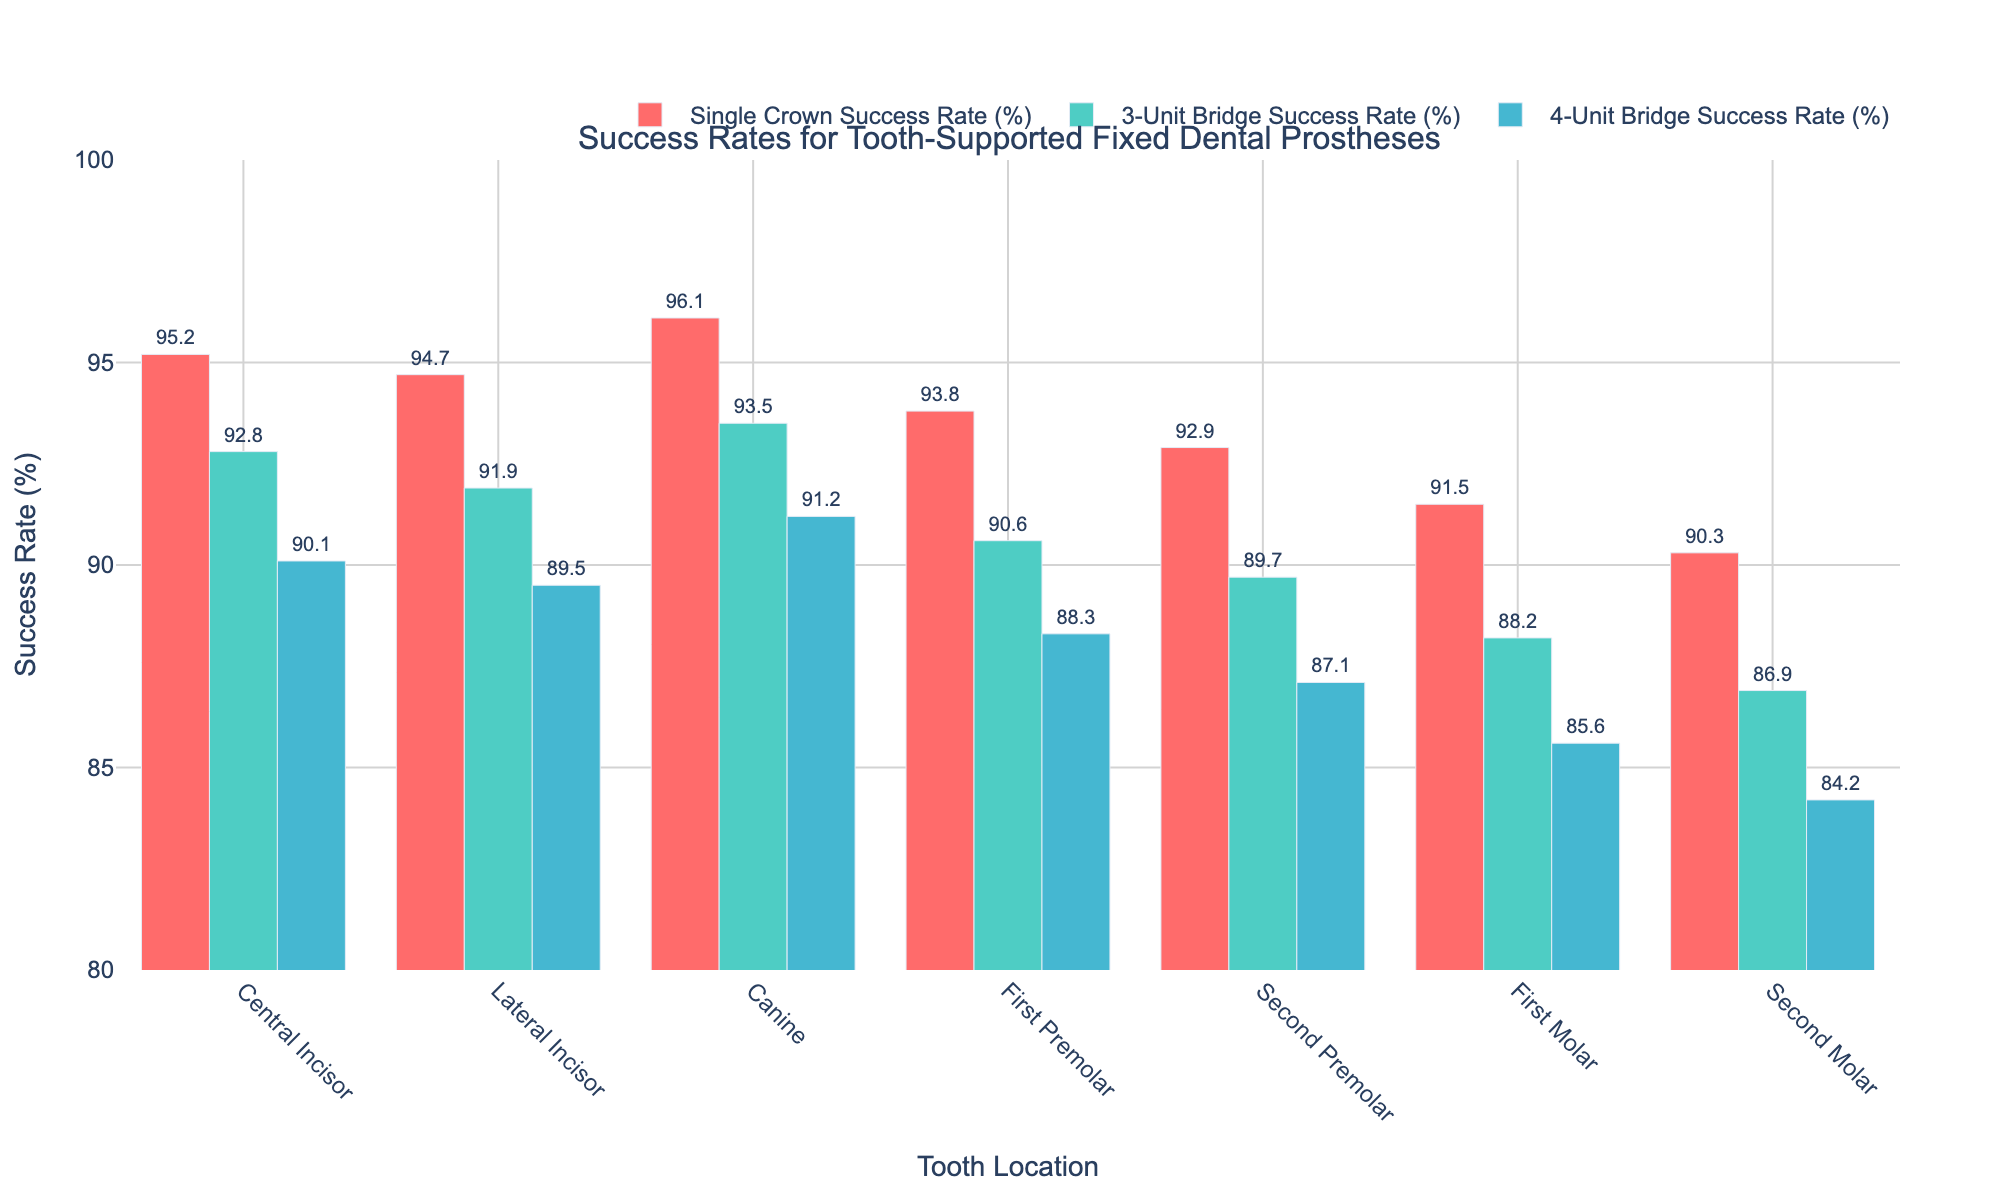What's the success rate of a 3-Unit Bridge for Canines? The figure shows a bar chart with success rates for various tooth-supported prostheses. Locate the bar for a 3-Unit Bridge under the "Canine" tooth location. The value is annotated directly on the bar.
Answer: 93.5% Which tooth location has the highest success rate for Single Crowns? Look at all the bars for Single Crown success rates across different tooth locations. The tallest bar corresponds to the highest success rate. Identify the tooth location.
Answer: Canine Comparing the success rates for Single Crowns and 4-Unit Bridges for the Central Incisor, which is higher? Locate the bars for Single Crowns and 4-Unit Bridges under the "Central Incisor" category. Compare their heights and the annotated values.
Answer: Single Crowns What is the difference in success rates between a 4-Unit Bridge for the First Molar and the Second Molar? Find the bars representing 4-Unit Bridge success rates for both the First and Second Molars. Subtract the success rate of the Second Molar from that of the First Molar.
Answer: 1.4% Which prosthesis type has the least variation in success rates across all tooth locations? Look at the range of heights (success rates) for each prosthesis type (Single Crown, 3-Unit Bridge, 4-Unit Bridge) across all tooth locations. The type with bars that have the smallest range of variation in height has the least variation.
Answer: 3-Unit Bridge What are the average success rates for 3-Unit Bridges and 4-Unit Bridges across all tooth locations? For 3-Unit Bridge: Sum the success rates for all tooth locations and divide by the number of locations. Similarly, do the same for 4-Unit Bridges. [3-Unit Bridge: (92.8 + 91.9 + 93.5 + 90.6 + 89.7 + 88.2 + 86.9) / 7 = 90.5, 4-Unit Bridge: (90.1 + 89.5 + 91.2 + 88.3 + 87.1 + 85.6 + 84.2) / 7 = 88.0]
Answer: 90.5%, 88.0% What's the difference in success rates between Single Crowns for Canines and Second Molars? Locate the Single Crown success rates for Canines and Second Molars. Subtract the success rate of the Second Molars from that of Canines.
Answer: 5.8% Between the First Premolar and Second Premolar, which has better success rates for Single Crowns and by how much? Compare the Single Crown success rates for First and Second Premolars by locating their respective bars. Subtract the Second Premolar's rate from the First Premolar's rate.
Answer: First Premolar by 0.9% Which tooth location has the lowest success rate for 4-Unit Bridges? Look at all the bars representing 4-Unit Bridge success rates and find the shortest one. Identify the corresponding tooth location.
Answer: Second Molar For which prosthesis type does the First Molar and First Premolar have an equal success rate? Locate the bars for the First Molar and First Premolar across each prosthesis type. Find the prosthesis type where the heights (values) of these bars are equal.
Answer: None 